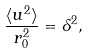Convert formula to latex. <formula><loc_0><loc_0><loc_500><loc_500>\frac { \langle u ^ { 2 } \rangle } { r _ { 0 } ^ { 2 } } = \delta ^ { 2 } ,</formula> 